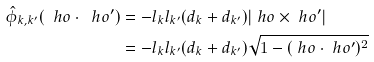Convert formula to latex. <formula><loc_0><loc_0><loc_500><loc_500>\hat { \phi } _ { k , k ^ { \prime } } ( \ h o \cdot \ h o ^ { \prime } ) & = - l _ { k } l _ { k ^ { \prime } } ( d _ { k } + d _ { k ^ { \prime } } ) | \ h o \times \ h o ^ { \prime } | \\ & = - l _ { k } l _ { k ^ { \prime } } ( d _ { k } + d _ { k ^ { \prime } } ) \sqrt { 1 - ( \ h o \cdot \ h o ^ { \prime } ) ^ { 2 } }</formula> 